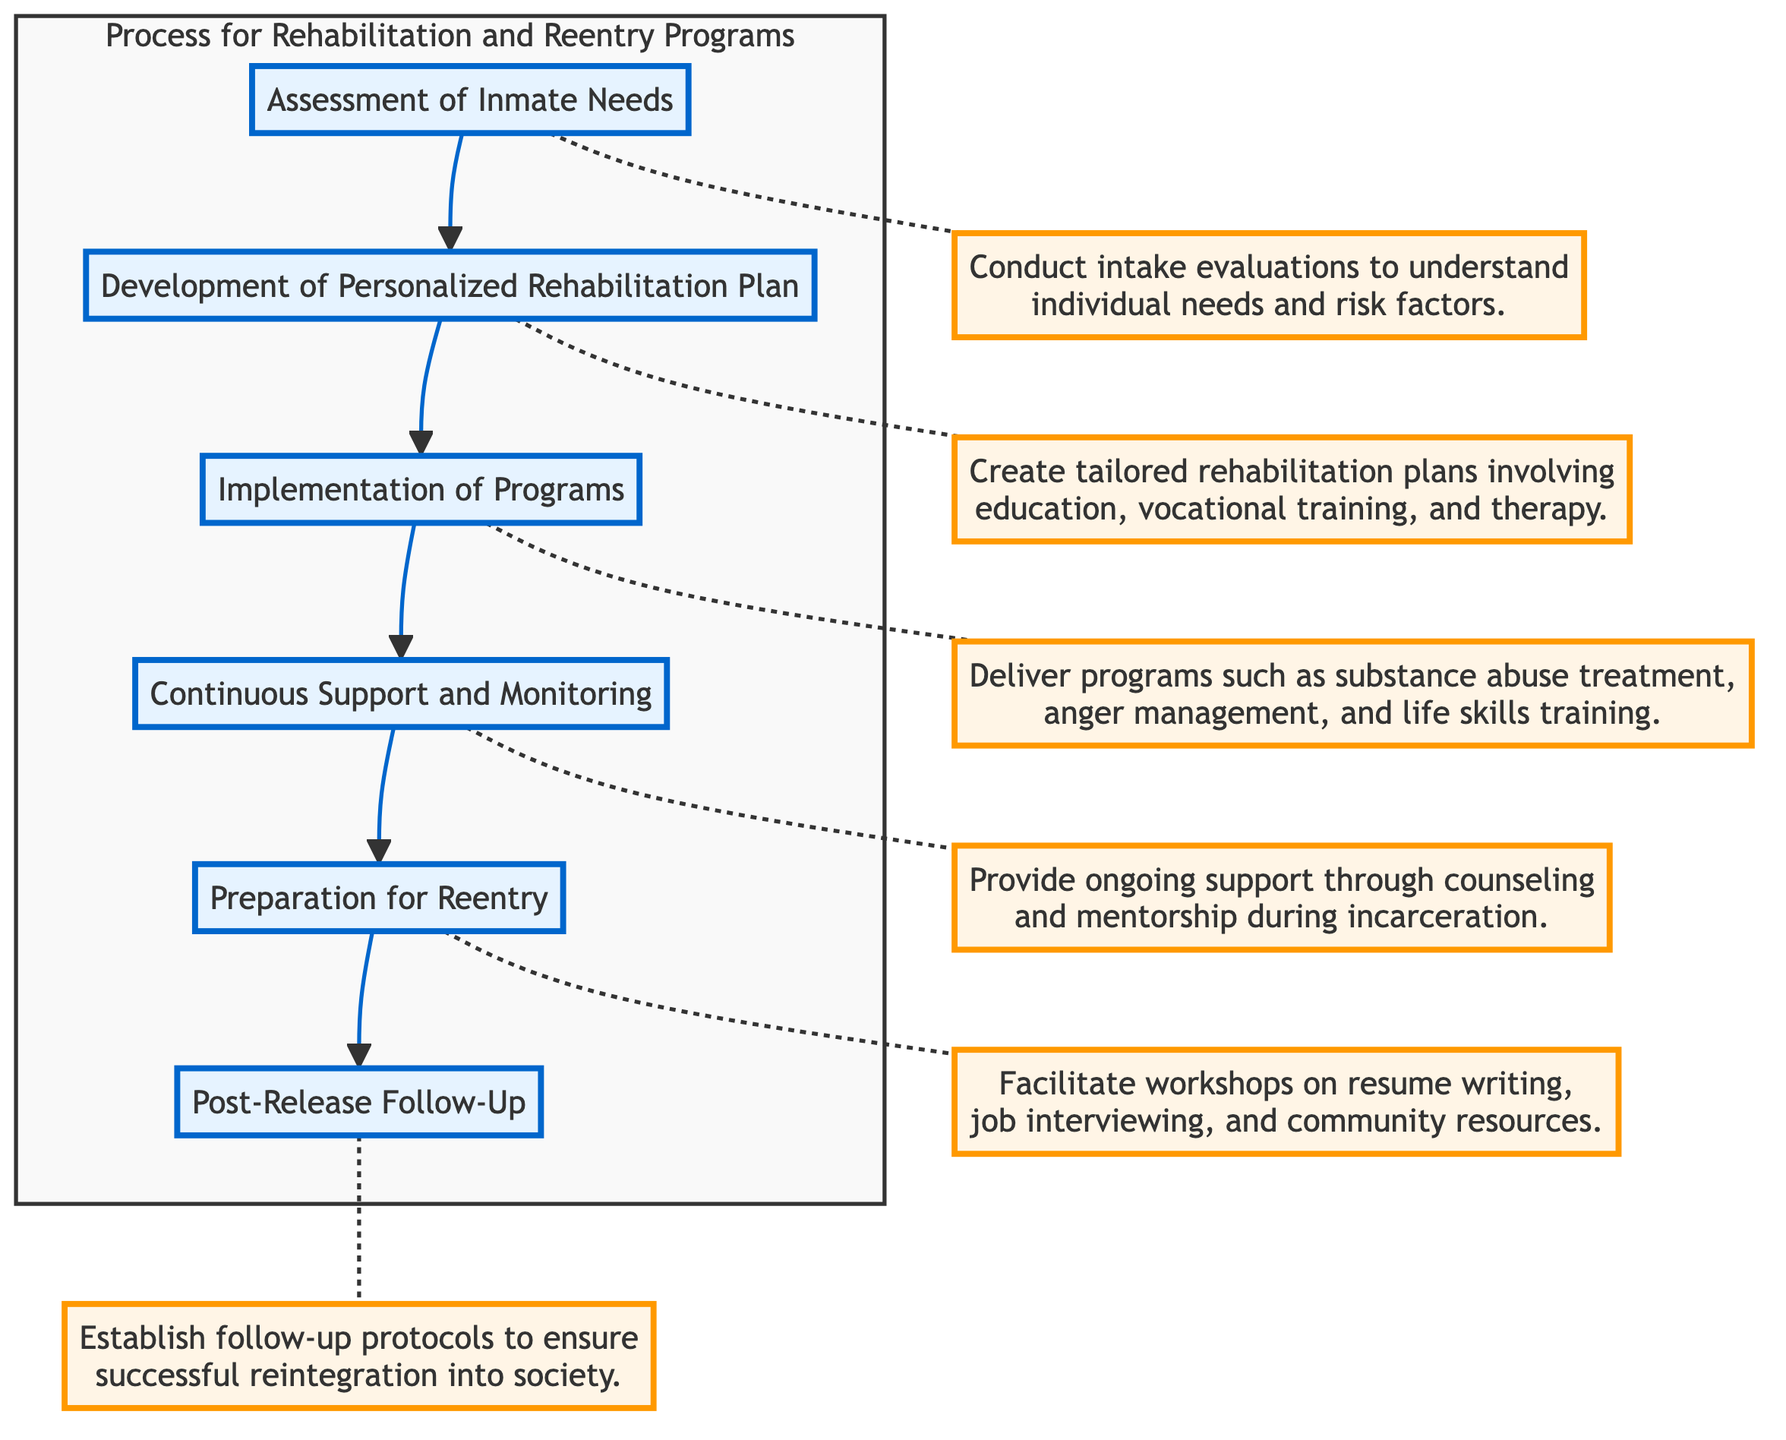What is the first step in the rehabilitation process? The first step in the diagram is labeled as "Assessment of Inmate Needs," indicating it's the initial phase of the rehabilitation process.
Answer: Assessment of Inmate Needs How many steps are included in the rehabilitation process? By counting the steps represented in the flowchart, there are a total of six distinct steps outlined in the process.
Answer: 6 What is the description associated with the third step? The third step is labeled "Implementation of Programs," and its description is to deliver programs such as substance abuse treatment, anger management, and life skills training.
Answer: Deliver programs such as substance abuse treatment, anger management, and life skills training Which step comes after "Continuous Support and Monitoring"? The diagram shows that the step following "Continuous Support and Monitoring" is "Preparation for Reentry," establishing a sequential flow from monitoring to reentry preparation.
Answer: Preparation for Reentry What type of support is provided during the fourth step? During the fourth step, "Continuous Support and Monitoring," the support provided includes ongoing counseling and mentorship during incarceration.
Answer: Ongoing support through counseling and mentorship What is the last step in the rehabilitation process? According to the flowchart, the last step is "Post-Release Follow-Up," which indicates the conclusion of the rehabilitation sequence leading into reintegration protocols.
Answer: Post-Release Follow-Up Which step involves creating tailored rehabilitation plans? The step titled "Development of Personalized Rehabilitation Plan" clearly states that it involves creating tailored rehabilitation plans, which focuses on individual needs.
Answer: Development of Personalized Rehabilitation Plan What are the components mentioned in the second step's description? The description associated with the second step highlights education, vocational training, and therapy as the components involved in the personalized rehabilitation plans.
Answer: Education, vocational training, and therapy 